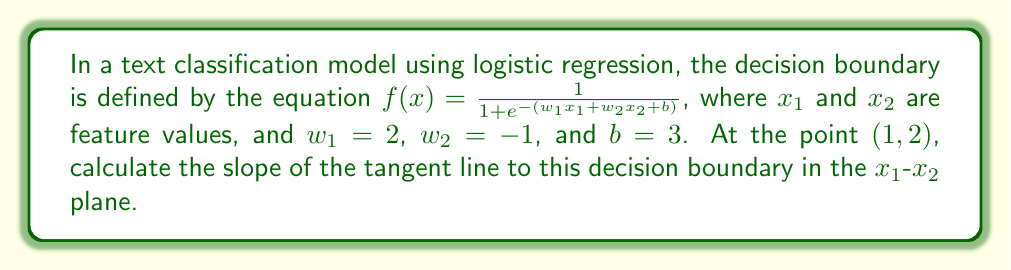Solve this math problem. To find the slope of the tangent line to the decision boundary, we need to follow these steps:

1) First, let's define our function $f(x_1, x_2)$:

   $f(x_1, x_2) = \frac{1}{1 + e^{-(2x_1 - x_2 + 3)}}$

2) To find the slope of the tangent line, we need to calculate the partial derivatives with respect to $x_1$ and $x_2$ at the point (1, 2):

   $\frac{\partial f}{\partial x_1} = f(x_1, x_2)(1 - f(x_1, x_2)) \cdot 2$
   $\frac{\partial f}{\partial x_2} = f(x_1, x_2)(1 - f(x_1, x_2)) \cdot (-1)$

3) Calculate $f(1, 2)$:

   $f(1, 2) = \frac{1}{1 + e^{-(2(1) - 2 + 3)}} = \frac{1}{1 + e^{-3}} \approx 0.9526$

4) Now, calculate the partial derivatives at (1, 2):

   $\frac{\partial f}{\partial x_1}|_{(1,2)} = 0.9526(1 - 0.9526) \cdot 2 \approx 0.0903$
   $\frac{\partial f}{\partial x_2}|_{(1,2)} = 0.9526(1 - 0.9526) \cdot (-1) \approx -0.0452$

5) The slope of the tangent line in the $x_1$-$x_2$ plane is given by:

   $\frac{dx_2}{dx_1} = -\frac{\frac{\partial f}{\partial x_1}}{\frac{\partial f}{\partial x_2}}$

6) Substituting our calculated values:

   $\frac{dx_2}{dx_1} = -\frac{0.0903}{-0.0452} \approx 2$

Therefore, the slope of the tangent line to the decision boundary at the point (1, 2) is approximately 2.
Answer: 2 